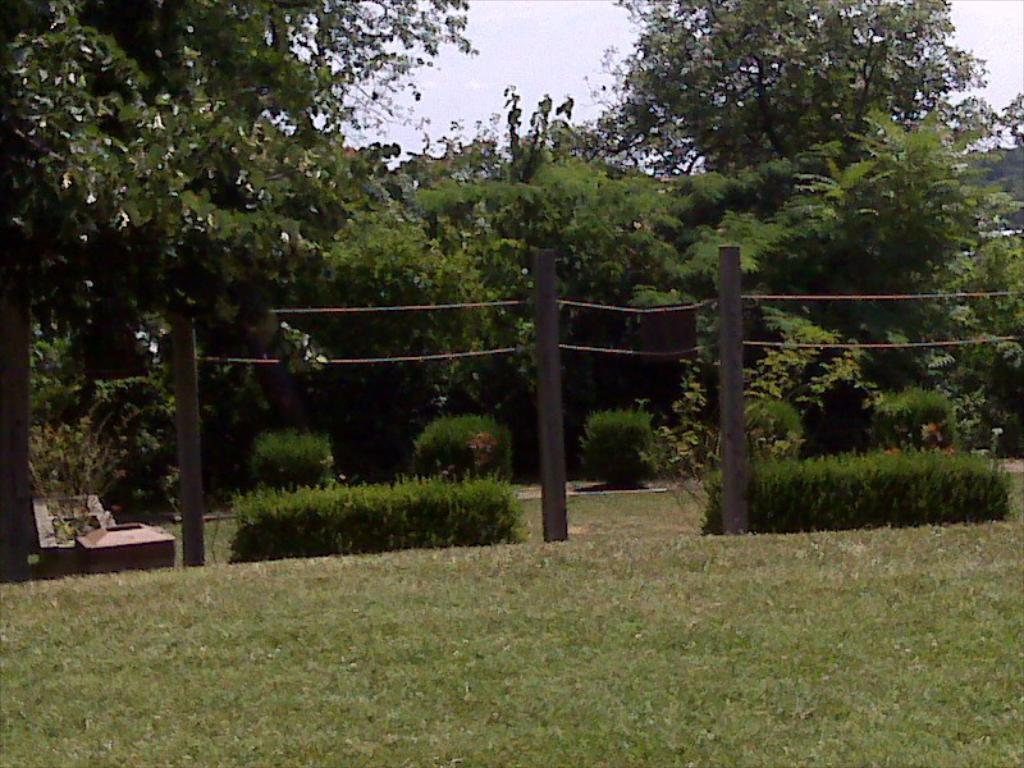What type of surface is on the floor in the image? There is grass on the floor in the image. What can be seen in the backdrop of the image? There are plants and trees in the backdrop of the image. What is the condition of the sky in the image? The sky is clear in the image. What type of soup is being served in the image? There is no soup present in the image; it features grass on the floor, plants and trees in the backdrop, and a clear sky. What type of harmony is depicted in the image? The image does not depict any specific harmony; it simply shows a natural setting with grass, plants, trees, and a clear sky. 